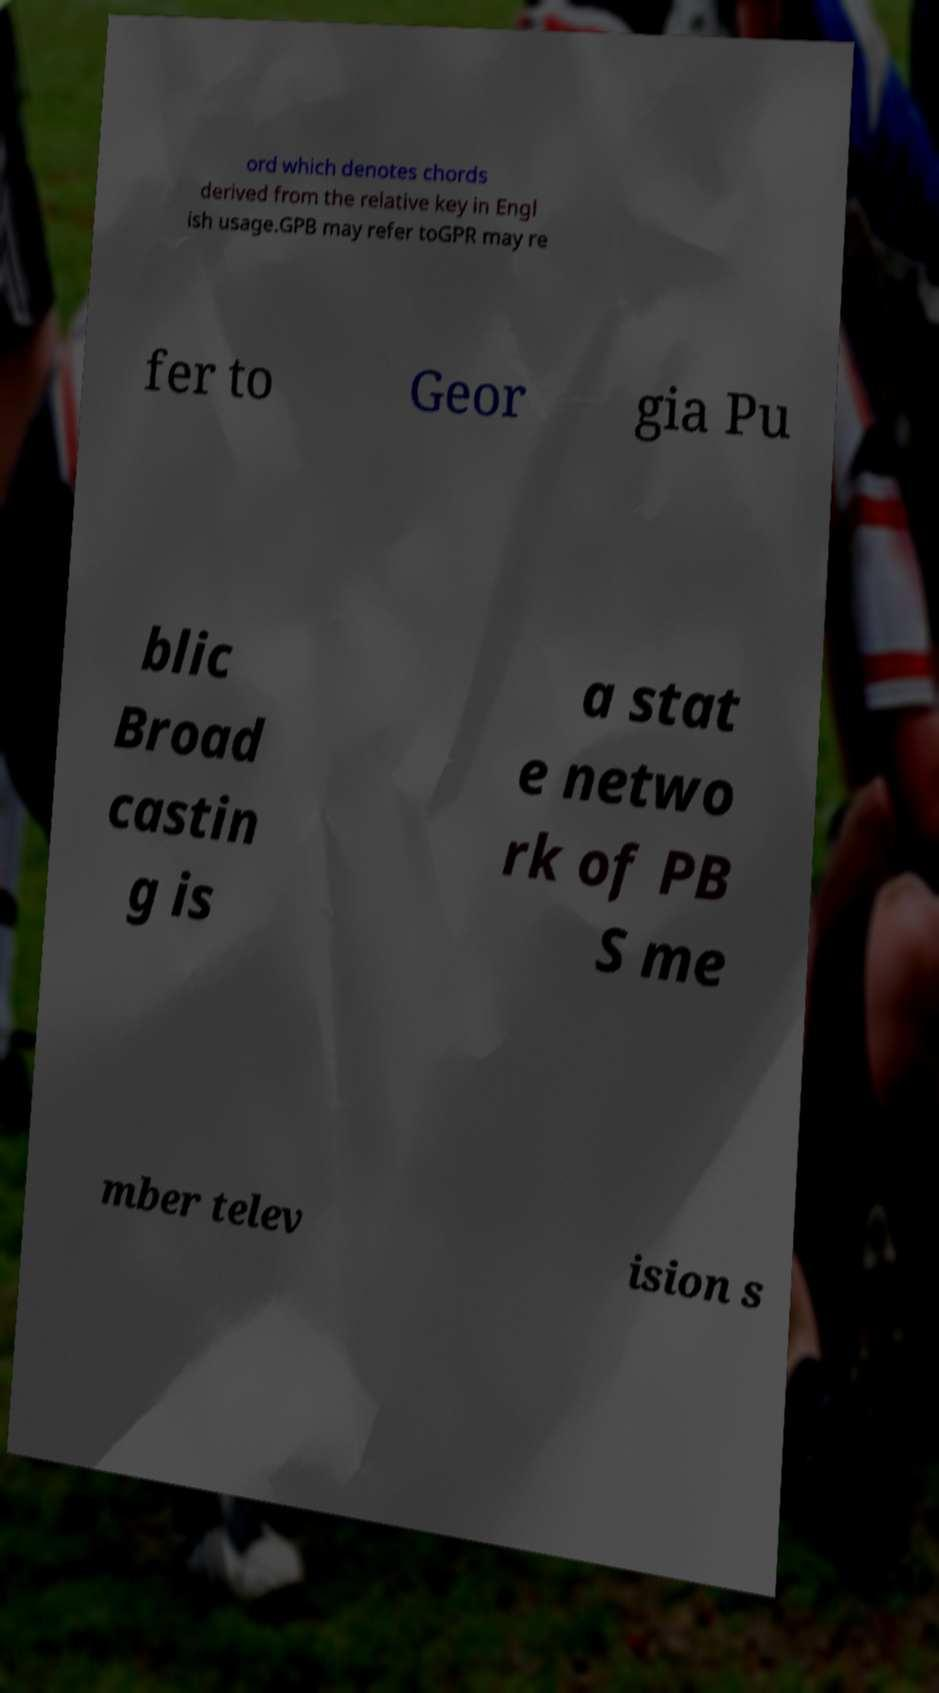What messages or text are displayed in this image? I need them in a readable, typed format. ord which denotes chords derived from the relative key in Engl ish usage.GPB may refer toGPR may re fer to Geor gia Pu blic Broad castin g is a stat e netwo rk of PB S me mber telev ision s 